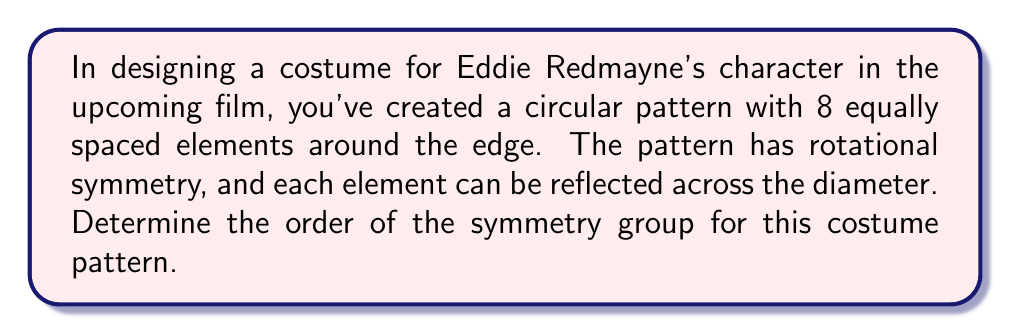Give your solution to this math problem. Let's approach this step-by-step:

1) First, we need to identify all the symmetries of the pattern:

   a) Rotational symmetries: The pattern can be rotated by multiples of 45° (360°/8) and still look the same. This gives us 8 rotational symmetries (including the identity rotation of 0°).

   b) Reflection symmetries: The pattern can be reflected across 4 lines of symmetry (2 diameters and 2 diagonals). This gives us 4 reflection symmetries.

2) The symmetry group of this pattern is known as the dihedral group $D_8$.

3) To determine the order of the group, we need to count the total number of distinct symmetries:
   
   $$\text{Total symmetries} = \text{Rotational symmetries} + \text{Reflection symmetries}$$
   $$\text{Total symmetries} = 8 + 4 = 12$$

4) We can verify this result using the formula for the order of a dihedral group $D_n$:

   $$|D_n| = 2n$$

   Where $n$ is the number of vertices (in this case, 8).

   $$|D_8| = 2(8) = 16$$

Therefore, the order of the symmetry group for this costume pattern is 16.

[asy]
unitsize(2cm);
for(int i=0; i<8; ++i) {
  dot(dir(45*i));
}
draw(circle((0,0),1));
draw((-1,0)--(1,0),dashed);
draw((0,-1)--(0,1),dashed);
draw((-1,-1)--(1,1),dashed);
draw((-1,1)--(1,-1),dashed);
[/asy]
Answer: The order of the symmetry group for the costume pattern is 16. 